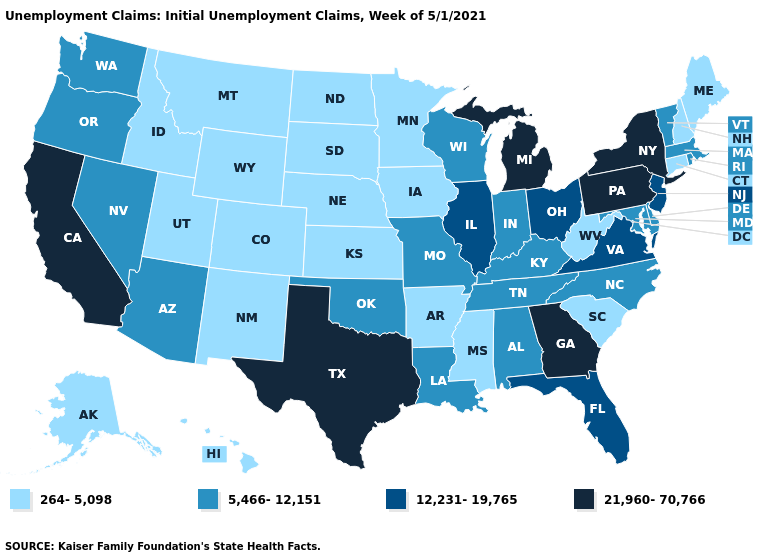Among the states that border Arkansas , does Tennessee have the highest value?
Short answer required. No. Does Texas have the highest value in the USA?
Give a very brief answer. Yes. Which states hav the highest value in the South?
Concise answer only. Georgia, Texas. Does Nevada have the lowest value in the West?
Write a very short answer. No. What is the value of Virginia?
Answer briefly. 12,231-19,765. Does Hawaii have the lowest value in the USA?
Write a very short answer. Yes. Name the states that have a value in the range 21,960-70,766?
Be succinct. California, Georgia, Michigan, New York, Pennsylvania, Texas. Does Arizona have the lowest value in the West?
Be succinct. No. Name the states that have a value in the range 21,960-70,766?
Concise answer only. California, Georgia, Michigan, New York, Pennsylvania, Texas. What is the highest value in the USA?
Concise answer only. 21,960-70,766. What is the value of Iowa?
Concise answer only. 264-5,098. What is the value of Massachusetts?
Short answer required. 5,466-12,151. Does Mississippi have the same value as Washington?
Give a very brief answer. No. What is the highest value in the USA?
Short answer required. 21,960-70,766. Name the states that have a value in the range 21,960-70,766?
Keep it brief. California, Georgia, Michigan, New York, Pennsylvania, Texas. 